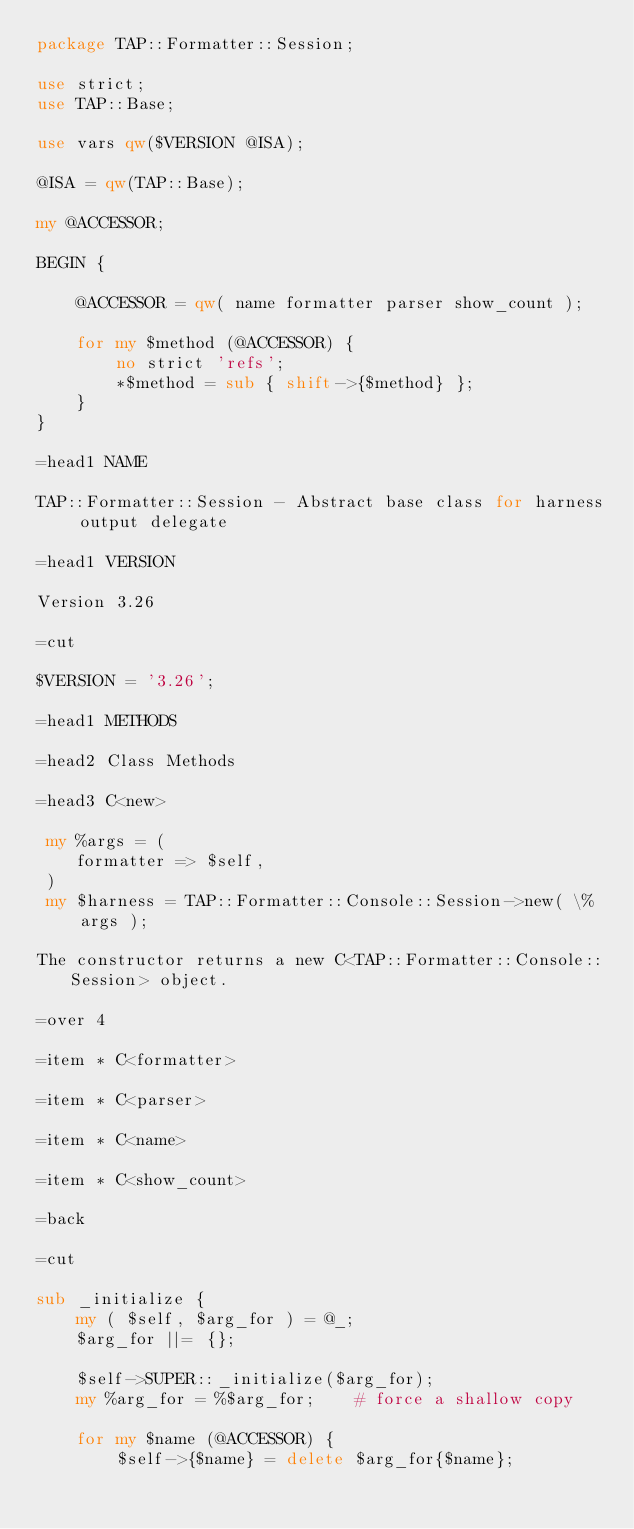<code> <loc_0><loc_0><loc_500><loc_500><_Perl_>package TAP::Formatter::Session;

use strict;
use TAP::Base;

use vars qw($VERSION @ISA);

@ISA = qw(TAP::Base);

my @ACCESSOR;

BEGIN {

    @ACCESSOR = qw( name formatter parser show_count );

    for my $method (@ACCESSOR) {
        no strict 'refs';
        *$method = sub { shift->{$method} };
    }
}

=head1 NAME

TAP::Formatter::Session - Abstract base class for harness output delegate 

=head1 VERSION

Version 3.26

=cut

$VERSION = '3.26';

=head1 METHODS

=head2 Class Methods

=head3 C<new>

 my %args = (
    formatter => $self,
 )
 my $harness = TAP::Formatter::Console::Session->new( \%args );

The constructor returns a new C<TAP::Formatter::Console::Session> object.

=over 4

=item * C<formatter>

=item * C<parser>

=item * C<name>

=item * C<show_count>

=back

=cut

sub _initialize {
    my ( $self, $arg_for ) = @_;
    $arg_for ||= {};

    $self->SUPER::_initialize($arg_for);
    my %arg_for = %$arg_for;    # force a shallow copy

    for my $name (@ACCESSOR) {
        $self->{$name} = delete $arg_for{$name};</code> 